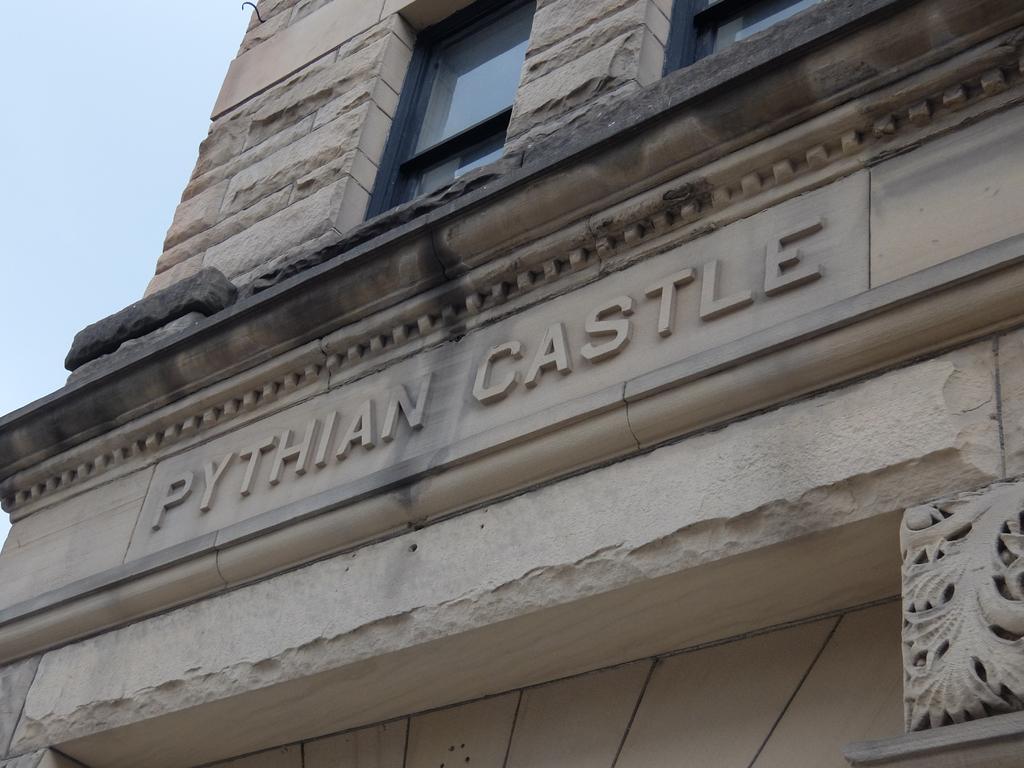How would you summarize this image in a sentence or two? In this image we can see a building with windows. We can also see the sky. 